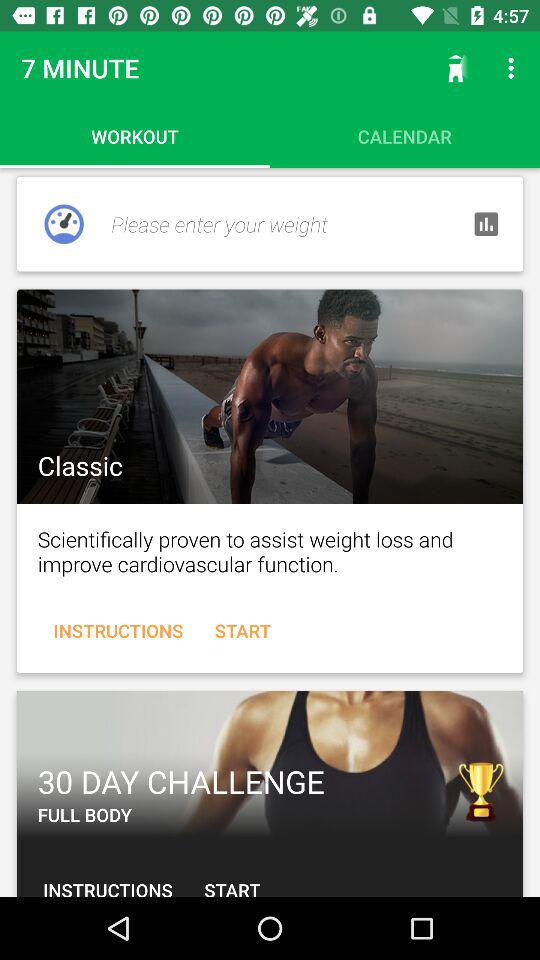How many days of the challenge are there? There are 30 days of the challenge. 